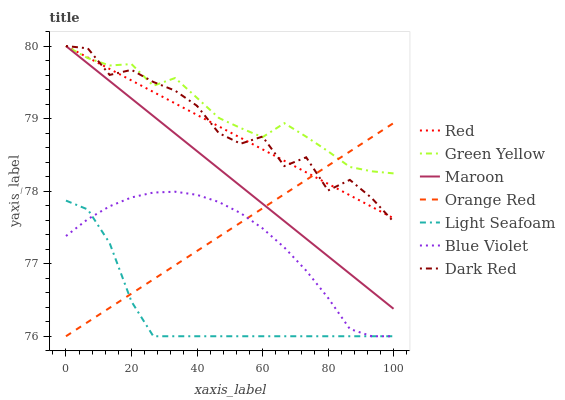Does Light Seafoam have the minimum area under the curve?
Answer yes or no. Yes. Does Green Yellow have the maximum area under the curve?
Answer yes or no. Yes. Does Dark Red have the minimum area under the curve?
Answer yes or no. No. Does Dark Red have the maximum area under the curve?
Answer yes or no. No. Is Orange Red the smoothest?
Answer yes or no. Yes. Is Dark Red the roughest?
Answer yes or no. Yes. Is Maroon the smoothest?
Answer yes or no. No. Is Maroon the roughest?
Answer yes or no. No. Does Light Seafoam have the lowest value?
Answer yes or no. Yes. Does Dark Red have the lowest value?
Answer yes or no. No. Does Red have the highest value?
Answer yes or no. Yes. Does Light Seafoam have the highest value?
Answer yes or no. No. Is Light Seafoam less than Maroon?
Answer yes or no. Yes. Is Red greater than Light Seafoam?
Answer yes or no. Yes. Does Maroon intersect Red?
Answer yes or no. Yes. Is Maroon less than Red?
Answer yes or no. No. Is Maroon greater than Red?
Answer yes or no. No. Does Light Seafoam intersect Maroon?
Answer yes or no. No. 